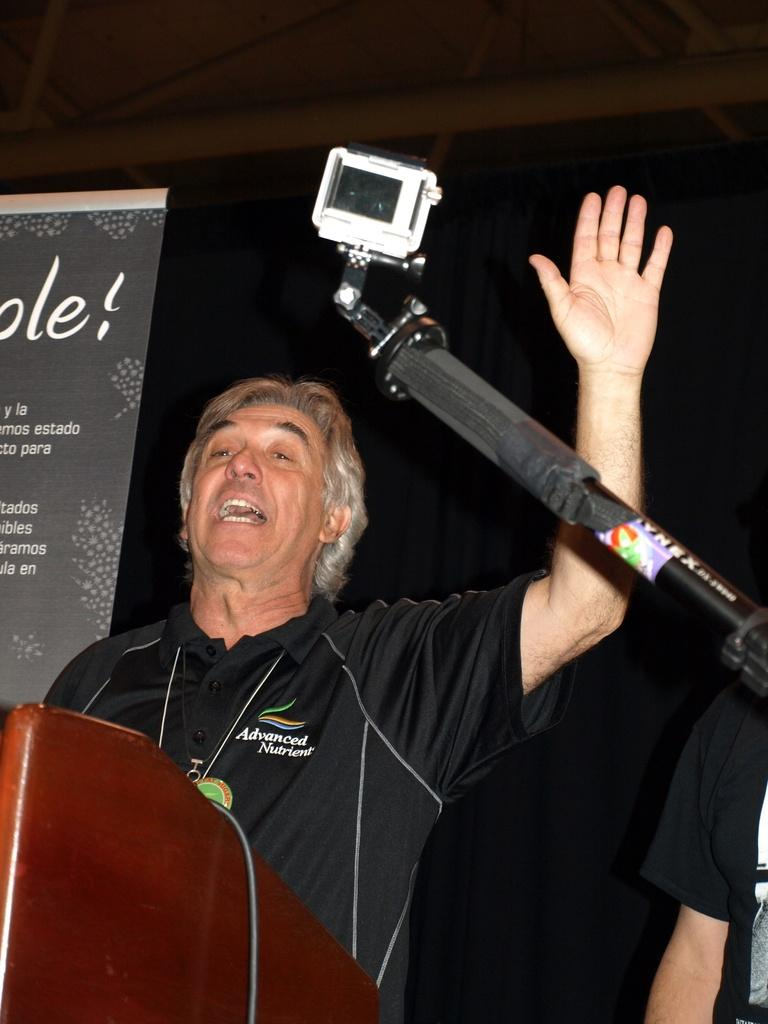What is the main subject of the image? There is a man standing in the image. What object can be seen on the right side of the image? There is a camera on the right side of the image. What is on the left side of the image? There is a poster on the left side of the image. How would you describe the background of the image? The background of the image is dark. What type of desk is visible in the image? There is no desk present in the image. Can you tell me how many additions are made to the poster in the image? There is no indication of any additions being made to the poster in the image. 